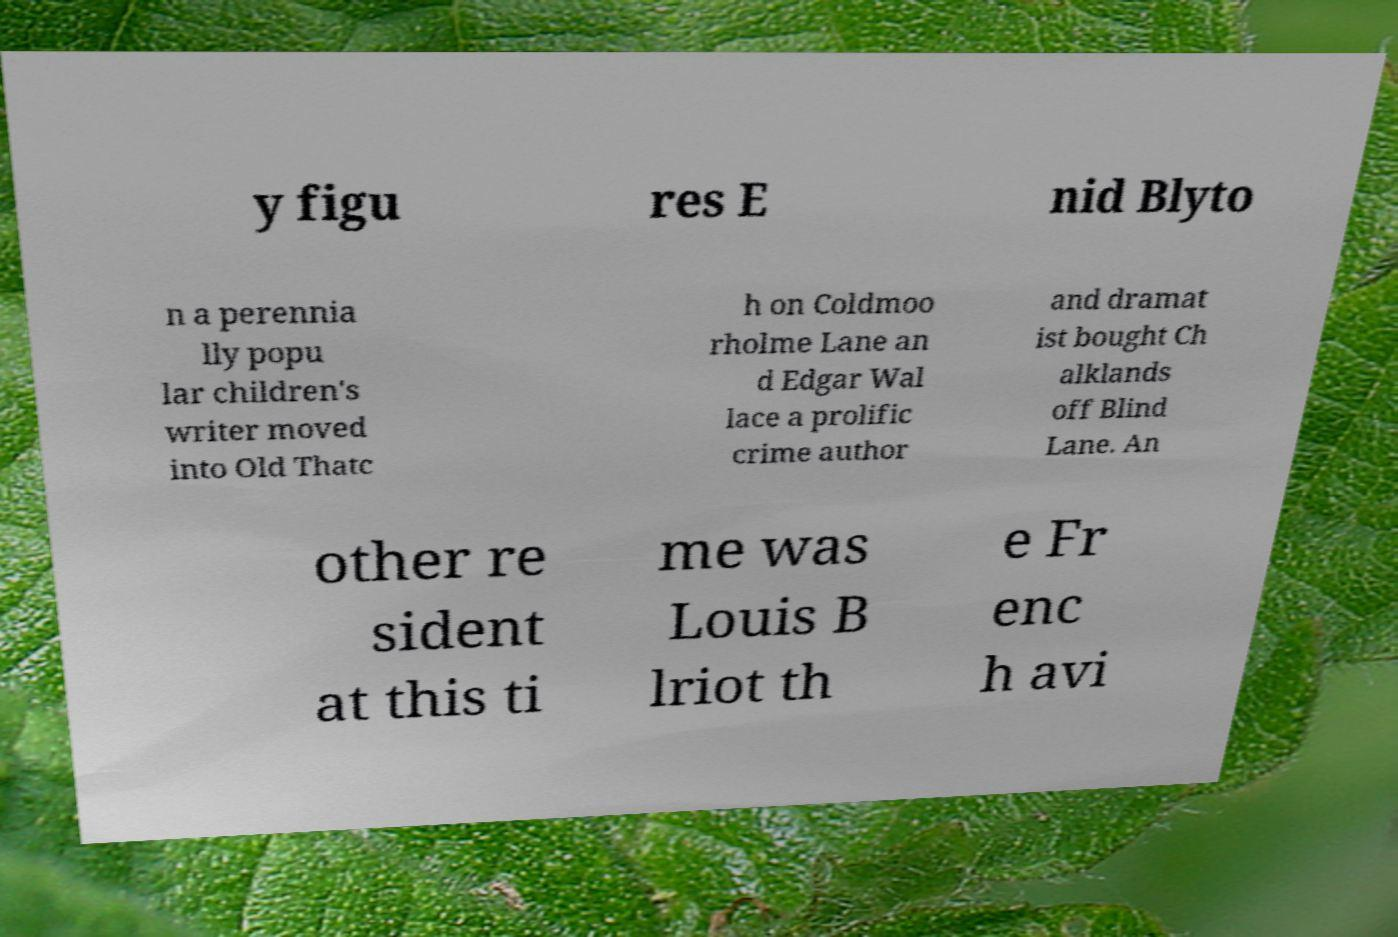Could you extract and type out the text from this image? y figu res E nid Blyto n a perennia lly popu lar children's writer moved into Old Thatc h on Coldmoo rholme Lane an d Edgar Wal lace a prolific crime author and dramat ist bought Ch alklands off Blind Lane. An other re sident at this ti me was Louis B lriot th e Fr enc h avi 